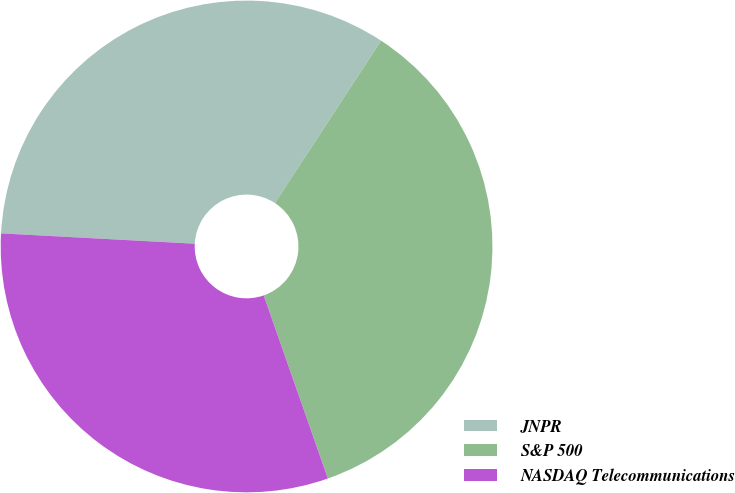Convert chart. <chart><loc_0><loc_0><loc_500><loc_500><pie_chart><fcel>JNPR<fcel>S&P 500<fcel>NASDAQ Telecommunications<nl><fcel>33.36%<fcel>35.42%<fcel>31.21%<nl></chart> 